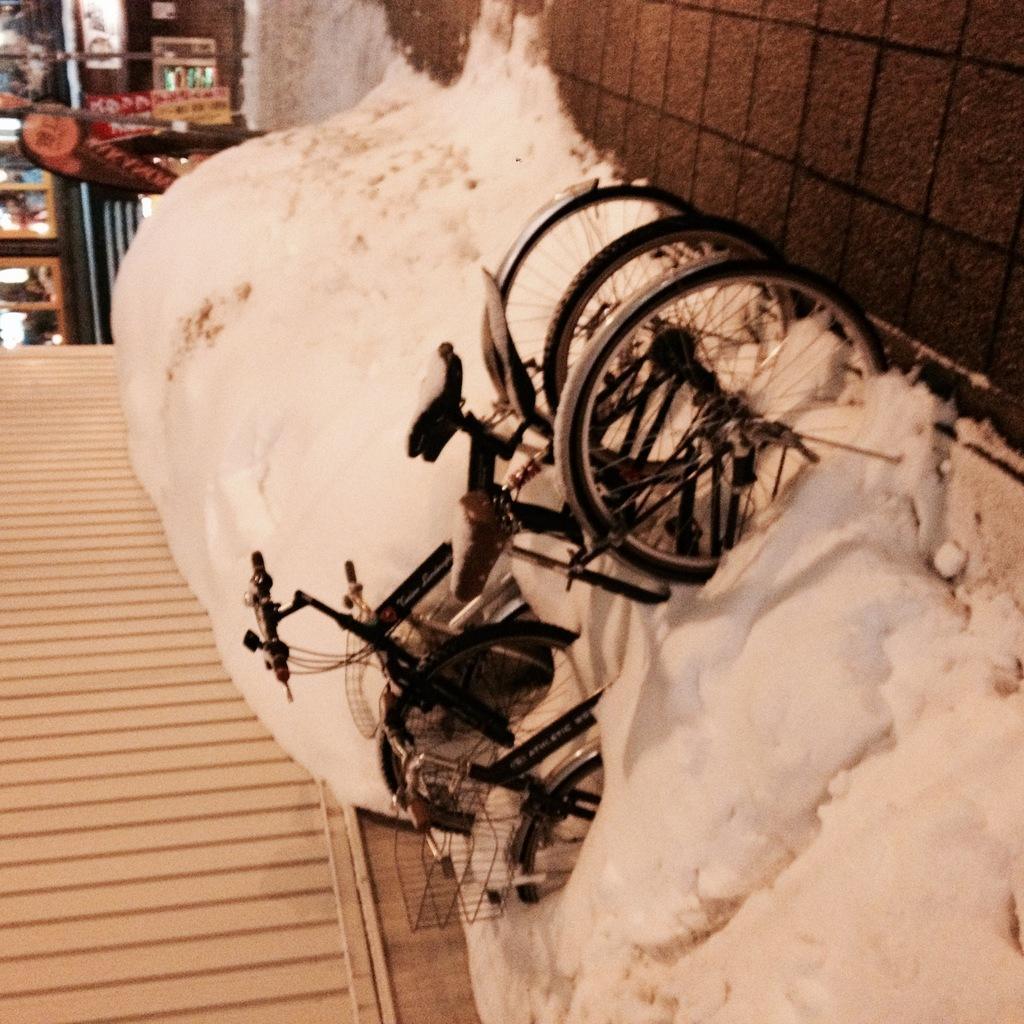How would you summarize this image in a sentence or two? In this picture, we can see bicycles, snow on the ground, stores, wall and some posters. 